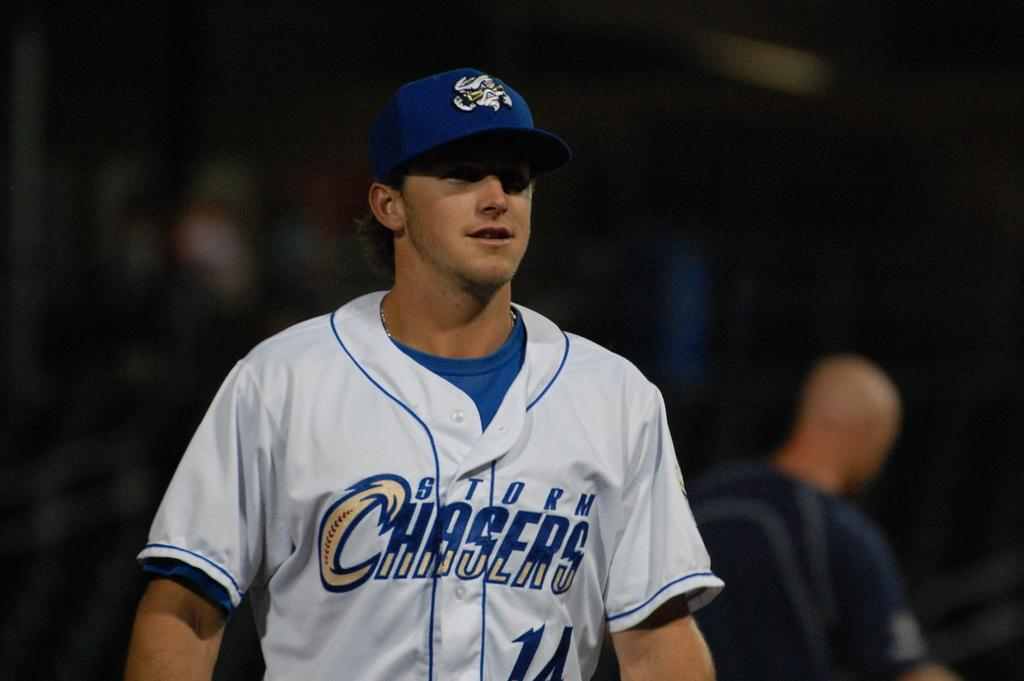What is the main subject of the image? There is a man standing in the center of the image. What is the man in the center wearing? The man in the center is wearing a cap. Can you describe the other person in the image? There is another man in the background of the image. What type of tax is being discussed by the man in the image? There is no indication in the image that a tax discussion is taking place. 